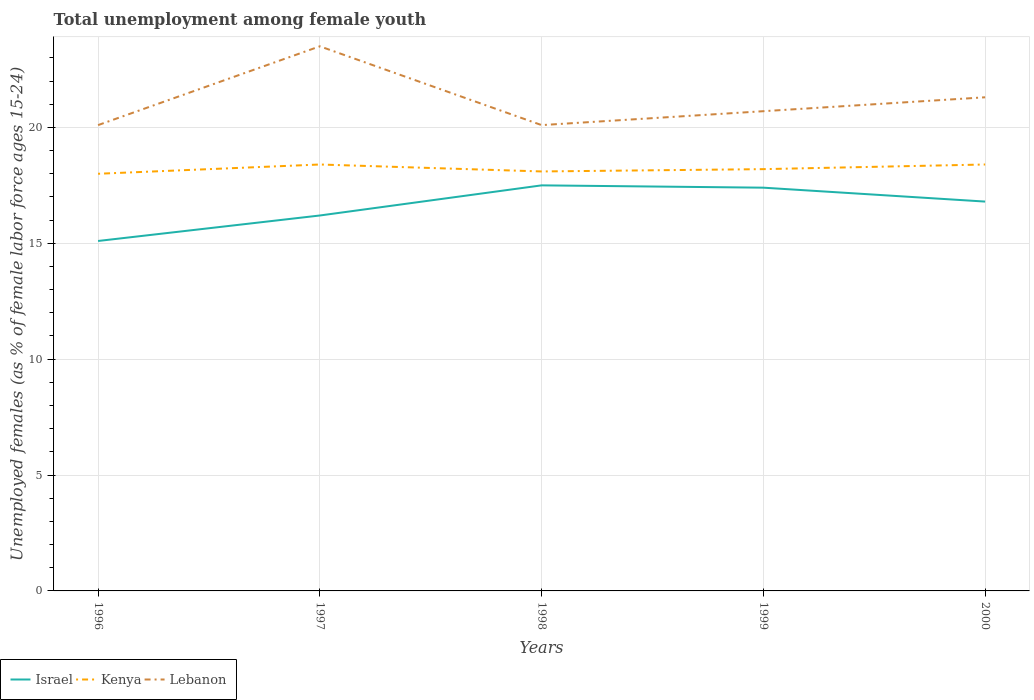Is the number of lines equal to the number of legend labels?
Make the answer very short. Yes. Across all years, what is the maximum percentage of unemployed females in in Lebanon?
Offer a terse response. 20.1. What is the total percentage of unemployed females in in Israel in the graph?
Make the answer very short. -2.3. What is the difference between the highest and the second highest percentage of unemployed females in in Israel?
Offer a very short reply. 2.4. Are the values on the major ticks of Y-axis written in scientific E-notation?
Give a very brief answer. No. Does the graph contain grids?
Ensure brevity in your answer.  Yes. How many legend labels are there?
Ensure brevity in your answer.  3. How are the legend labels stacked?
Keep it short and to the point. Horizontal. What is the title of the graph?
Provide a short and direct response. Total unemployment among female youth. Does "Gambia, The" appear as one of the legend labels in the graph?
Provide a succinct answer. No. What is the label or title of the X-axis?
Provide a succinct answer. Years. What is the label or title of the Y-axis?
Provide a succinct answer. Unemployed females (as % of female labor force ages 15-24). What is the Unemployed females (as % of female labor force ages 15-24) in Israel in 1996?
Give a very brief answer. 15.1. What is the Unemployed females (as % of female labor force ages 15-24) in Lebanon in 1996?
Your answer should be very brief. 20.1. What is the Unemployed females (as % of female labor force ages 15-24) in Israel in 1997?
Your answer should be compact. 16.2. What is the Unemployed females (as % of female labor force ages 15-24) of Kenya in 1997?
Your response must be concise. 18.4. What is the Unemployed females (as % of female labor force ages 15-24) in Lebanon in 1997?
Your response must be concise. 23.5. What is the Unemployed females (as % of female labor force ages 15-24) of Kenya in 1998?
Your response must be concise. 18.1. What is the Unemployed females (as % of female labor force ages 15-24) of Lebanon in 1998?
Make the answer very short. 20.1. What is the Unemployed females (as % of female labor force ages 15-24) in Israel in 1999?
Ensure brevity in your answer.  17.4. What is the Unemployed females (as % of female labor force ages 15-24) of Kenya in 1999?
Your response must be concise. 18.2. What is the Unemployed females (as % of female labor force ages 15-24) in Lebanon in 1999?
Your answer should be compact. 20.7. What is the Unemployed females (as % of female labor force ages 15-24) of Israel in 2000?
Provide a succinct answer. 16.8. What is the Unemployed females (as % of female labor force ages 15-24) in Kenya in 2000?
Provide a succinct answer. 18.4. What is the Unemployed females (as % of female labor force ages 15-24) in Lebanon in 2000?
Keep it short and to the point. 21.3. Across all years, what is the maximum Unemployed females (as % of female labor force ages 15-24) of Israel?
Provide a short and direct response. 17.5. Across all years, what is the maximum Unemployed females (as % of female labor force ages 15-24) in Kenya?
Keep it short and to the point. 18.4. Across all years, what is the minimum Unemployed females (as % of female labor force ages 15-24) in Israel?
Give a very brief answer. 15.1. Across all years, what is the minimum Unemployed females (as % of female labor force ages 15-24) in Kenya?
Your response must be concise. 18. Across all years, what is the minimum Unemployed females (as % of female labor force ages 15-24) in Lebanon?
Provide a succinct answer. 20.1. What is the total Unemployed females (as % of female labor force ages 15-24) of Kenya in the graph?
Make the answer very short. 91.1. What is the total Unemployed females (as % of female labor force ages 15-24) in Lebanon in the graph?
Give a very brief answer. 105.7. What is the difference between the Unemployed females (as % of female labor force ages 15-24) of Lebanon in 1996 and that in 1998?
Make the answer very short. 0. What is the difference between the Unemployed females (as % of female labor force ages 15-24) of Israel in 1996 and that in 1999?
Offer a very short reply. -2.3. What is the difference between the Unemployed females (as % of female labor force ages 15-24) of Lebanon in 1996 and that in 1999?
Provide a succinct answer. -0.6. What is the difference between the Unemployed females (as % of female labor force ages 15-24) of Israel in 1996 and that in 2000?
Give a very brief answer. -1.7. What is the difference between the Unemployed females (as % of female labor force ages 15-24) of Kenya in 1997 and that in 1998?
Offer a terse response. 0.3. What is the difference between the Unemployed females (as % of female labor force ages 15-24) of Lebanon in 1997 and that in 1998?
Provide a succinct answer. 3.4. What is the difference between the Unemployed females (as % of female labor force ages 15-24) of Lebanon in 1998 and that in 1999?
Your answer should be very brief. -0.6. What is the difference between the Unemployed females (as % of female labor force ages 15-24) of Israel in 1998 and that in 2000?
Provide a succinct answer. 0.7. What is the difference between the Unemployed females (as % of female labor force ages 15-24) of Kenya in 1996 and the Unemployed females (as % of female labor force ages 15-24) of Lebanon in 1997?
Ensure brevity in your answer.  -5.5. What is the difference between the Unemployed females (as % of female labor force ages 15-24) of Israel in 1996 and the Unemployed females (as % of female labor force ages 15-24) of Kenya in 1998?
Provide a short and direct response. -3. What is the difference between the Unemployed females (as % of female labor force ages 15-24) of Israel in 1996 and the Unemployed females (as % of female labor force ages 15-24) of Lebanon in 1998?
Your response must be concise. -5. What is the difference between the Unemployed females (as % of female labor force ages 15-24) of Israel in 1996 and the Unemployed females (as % of female labor force ages 15-24) of Kenya in 1999?
Make the answer very short. -3.1. What is the difference between the Unemployed females (as % of female labor force ages 15-24) of Kenya in 1996 and the Unemployed females (as % of female labor force ages 15-24) of Lebanon in 1999?
Give a very brief answer. -2.7. What is the difference between the Unemployed females (as % of female labor force ages 15-24) of Israel in 1996 and the Unemployed females (as % of female labor force ages 15-24) of Kenya in 2000?
Your answer should be compact. -3.3. What is the difference between the Unemployed females (as % of female labor force ages 15-24) of Kenya in 1996 and the Unemployed females (as % of female labor force ages 15-24) of Lebanon in 2000?
Give a very brief answer. -3.3. What is the difference between the Unemployed females (as % of female labor force ages 15-24) of Israel in 1997 and the Unemployed females (as % of female labor force ages 15-24) of Kenya in 1998?
Keep it short and to the point. -1.9. What is the difference between the Unemployed females (as % of female labor force ages 15-24) of Israel in 1997 and the Unemployed females (as % of female labor force ages 15-24) of Lebanon in 1998?
Offer a very short reply. -3.9. What is the difference between the Unemployed females (as % of female labor force ages 15-24) of Israel in 1997 and the Unemployed females (as % of female labor force ages 15-24) of Lebanon in 1999?
Your response must be concise. -4.5. What is the difference between the Unemployed females (as % of female labor force ages 15-24) in Kenya in 1997 and the Unemployed females (as % of female labor force ages 15-24) in Lebanon in 1999?
Make the answer very short. -2.3. What is the difference between the Unemployed females (as % of female labor force ages 15-24) in Israel in 1997 and the Unemployed females (as % of female labor force ages 15-24) in Kenya in 2000?
Ensure brevity in your answer.  -2.2. What is the difference between the Unemployed females (as % of female labor force ages 15-24) in Israel in 1998 and the Unemployed females (as % of female labor force ages 15-24) in Kenya in 1999?
Provide a succinct answer. -0.7. What is the difference between the Unemployed females (as % of female labor force ages 15-24) in Israel in 1998 and the Unemployed females (as % of female labor force ages 15-24) in Lebanon in 1999?
Make the answer very short. -3.2. What is the difference between the Unemployed females (as % of female labor force ages 15-24) in Kenya in 1998 and the Unemployed females (as % of female labor force ages 15-24) in Lebanon in 1999?
Offer a very short reply. -2.6. What is the difference between the Unemployed females (as % of female labor force ages 15-24) of Israel in 1998 and the Unemployed females (as % of female labor force ages 15-24) of Lebanon in 2000?
Provide a succinct answer. -3.8. What is the difference between the Unemployed females (as % of female labor force ages 15-24) of Kenya in 1998 and the Unemployed females (as % of female labor force ages 15-24) of Lebanon in 2000?
Ensure brevity in your answer.  -3.2. What is the difference between the Unemployed females (as % of female labor force ages 15-24) in Israel in 1999 and the Unemployed females (as % of female labor force ages 15-24) in Kenya in 2000?
Make the answer very short. -1. What is the difference between the Unemployed females (as % of female labor force ages 15-24) of Kenya in 1999 and the Unemployed females (as % of female labor force ages 15-24) of Lebanon in 2000?
Keep it short and to the point. -3.1. What is the average Unemployed females (as % of female labor force ages 15-24) in Kenya per year?
Provide a succinct answer. 18.22. What is the average Unemployed females (as % of female labor force ages 15-24) in Lebanon per year?
Your answer should be compact. 21.14. In the year 1996, what is the difference between the Unemployed females (as % of female labor force ages 15-24) of Israel and Unemployed females (as % of female labor force ages 15-24) of Lebanon?
Provide a short and direct response. -5. In the year 1996, what is the difference between the Unemployed females (as % of female labor force ages 15-24) in Kenya and Unemployed females (as % of female labor force ages 15-24) in Lebanon?
Provide a short and direct response. -2.1. In the year 1997, what is the difference between the Unemployed females (as % of female labor force ages 15-24) in Israel and Unemployed females (as % of female labor force ages 15-24) in Kenya?
Ensure brevity in your answer.  -2.2. In the year 1998, what is the difference between the Unemployed females (as % of female labor force ages 15-24) in Israel and Unemployed females (as % of female labor force ages 15-24) in Lebanon?
Offer a terse response. -2.6. In the year 1999, what is the difference between the Unemployed females (as % of female labor force ages 15-24) in Israel and Unemployed females (as % of female labor force ages 15-24) in Kenya?
Ensure brevity in your answer.  -0.8. In the year 1999, what is the difference between the Unemployed females (as % of female labor force ages 15-24) in Israel and Unemployed females (as % of female labor force ages 15-24) in Lebanon?
Keep it short and to the point. -3.3. In the year 1999, what is the difference between the Unemployed females (as % of female labor force ages 15-24) of Kenya and Unemployed females (as % of female labor force ages 15-24) of Lebanon?
Provide a short and direct response. -2.5. In the year 2000, what is the difference between the Unemployed females (as % of female labor force ages 15-24) of Israel and Unemployed females (as % of female labor force ages 15-24) of Kenya?
Your response must be concise. -1.6. In the year 2000, what is the difference between the Unemployed females (as % of female labor force ages 15-24) in Israel and Unemployed females (as % of female labor force ages 15-24) in Lebanon?
Give a very brief answer. -4.5. What is the ratio of the Unemployed females (as % of female labor force ages 15-24) of Israel in 1996 to that in 1997?
Offer a terse response. 0.93. What is the ratio of the Unemployed females (as % of female labor force ages 15-24) of Kenya in 1996 to that in 1997?
Give a very brief answer. 0.98. What is the ratio of the Unemployed females (as % of female labor force ages 15-24) in Lebanon in 1996 to that in 1997?
Make the answer very short. 0.86. What is the ratio of the Unemployed females (as % of female labor force ages 15-24) in Israel in 1996 to that in 1998?
Offer a very short reply. 0.86. What is the ratio of the Unemployed females (as % of female labor force ages 15-24) in Kenya in 1996 to that in 1998?
Ensure brevity in your answer.  0.99. What is the ratio of the Unemployed females (as % of female labor force ages 15-24) in Lebanon in 1996 to that in 1998?
Offer a very short reply. 1. What is the ratio of the Unemployed females (as % of female labor force ages 15-24) in Israel in 1996 to that in 1999?
Provide a short and direct response. 0.87. What is the ratio of the Unemployed females (as % of female labor force ages 15-24) of Israel in 1996 to that in 2000?
Offer a very short reply. 0.9. What is the ratio of the Unemployed females (as % of female labor force ages 15-24) in Kenya in 1996 to that in 2000?
Your answer should be compact. 0.98. What is the ratio of the Unemployed females (as % of female labor force ages 15-24) in Lebanon in 1996 to that in 2000?
Your answer should be very brief. 0.94. What is the ratio of the Unemployed females (as % of female labor force ages 15-24) in Israel in 1997 to that in 1998?
Make the answer very short. 0.93. What is the ratio of the Unemployed females (as % of female labor force ages 15-24) in Kenya in 1997 to that in 1998?
Offer a very short reply. 1.02. What is the ratio of the Unemployed females (as % of female labor force ages 15-24) in Lebanon in 1997 to that in 1998?
Make the answer very short. 1.17. What is the ratio of the Unemployed females (as % of female labor force ages 15-24) of Lebanon in 1997 to that in 1999?
Provide a short and direct response. 1.14. What is the ratio of the Unemployed females (as % of female labor force ages 15-24) in Kenya in 1997 to that in 2000?
Provide a short and direct response. 1. What is the ratio of the Unemployed females (as % of female labor force ages 15-24) in Lebanon in 1997 to that in 2000?
Your response must be concise. 1.1. What is the ratio of the Unemployed females (as % of female labor force ages 15-24) of Israel in 1998 to that in 1999?
Your response must be concise. 1.01. What is the ratio of the Unemployed females (as % of female labor force ages 15-24) of Kenya in 1998 to that in 1999?
Offer a very short reply. 0.99. What is the ratio of the Unemployed females (as % of female labor force ages 15-24) in Israel in 1998 to that in 2000?
Ensure brevity in your answer.  1.04. What is the ratio of the Unemployed females (as % of female labor force ages 15-24) in Kenya in 1998 to that in 2000?
Provide a succinct answer. 0.98. What is the ratio of the Unemployed females (as % of female labor force ages 15-24) in Lebanon in 1998 to that in 2000?
Provide a short and direct response. 0.94. What is the ratio of the Unemployed females (as % of female labor force ages 15-24) in Israel in 1999 to that in 2000?
Give a very brief answer. 1.04. What is the ratio of the Unemployed females (as % of female labor force ages 15-24) of Lebanon in 1999 to that in 2000?
Your answer should be compact. 0.97. What is the difference between the highest and the second highest Unemployed females (as % of female labor force ages 15-24) in Kenya?
Ensure brevity in your answer.  0. What is the difference between the highest and the lowest Unemployed females (as % of female labor force ages 15-24) of Israel?
Give a very brief answer. 2.4. What is the difference between the highest and the lowest Unemployed females (as % of female labor force ages 15-24) in Kenya?
Your response must be concise. 0.4. What is the difference between the highest and the lowest Unemployed females (as % of female labor force ages 15-24) of Lebanon?
Make the answer very short. 3.4. 